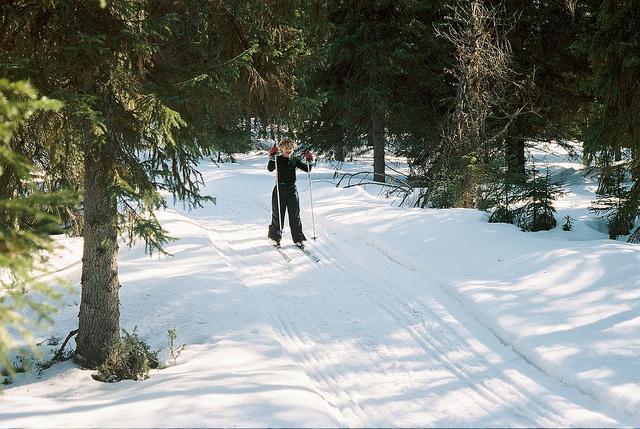How many skiers are pictured?
Give a very brief answer. 1. How many elephants are here?
Give a very brief answer. 0. 